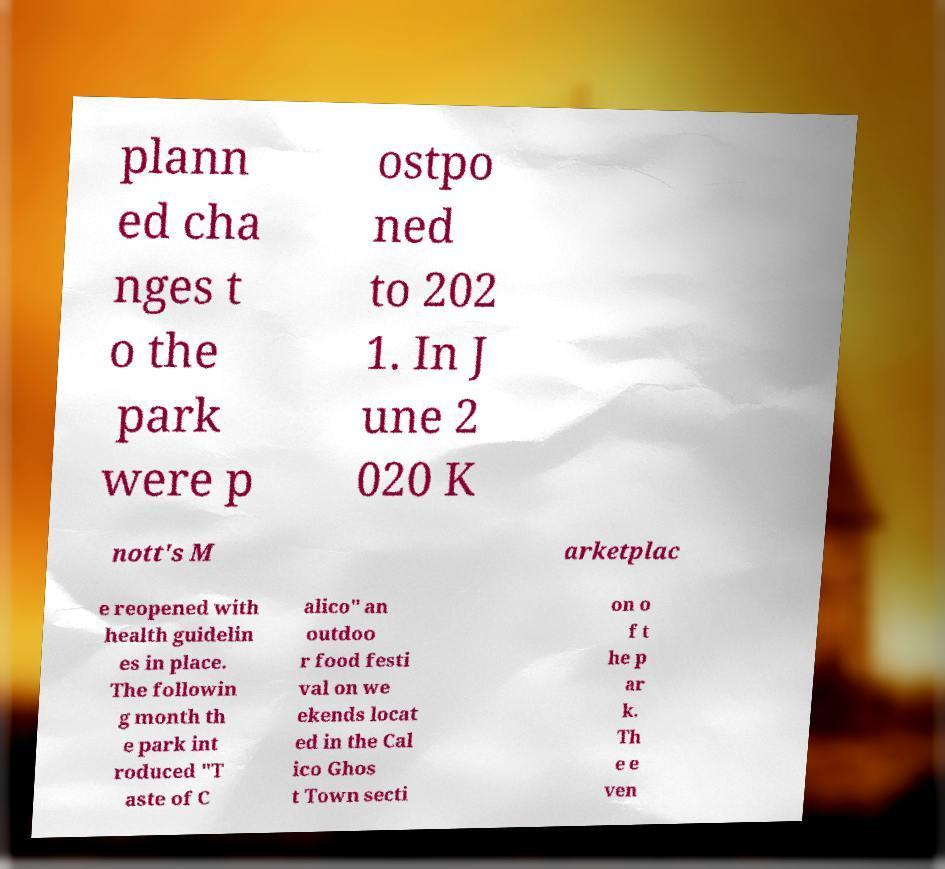Can you read and provide the text displayed in the image?This photo seems to have some interesting text. Can you extract and type it out for me? plann ed cha nges t o the park were p ostpo ned to 202 1. In J une 2 020 K nott's M arketplac e reopened with health guidelin es in place. The followin g month th e park int roduced "T aste of C alico" an outdoo r food festi val on we ekends locat ed in the Cal ico Ghos t Town secti on o f t he p ar k. Th e e ven 